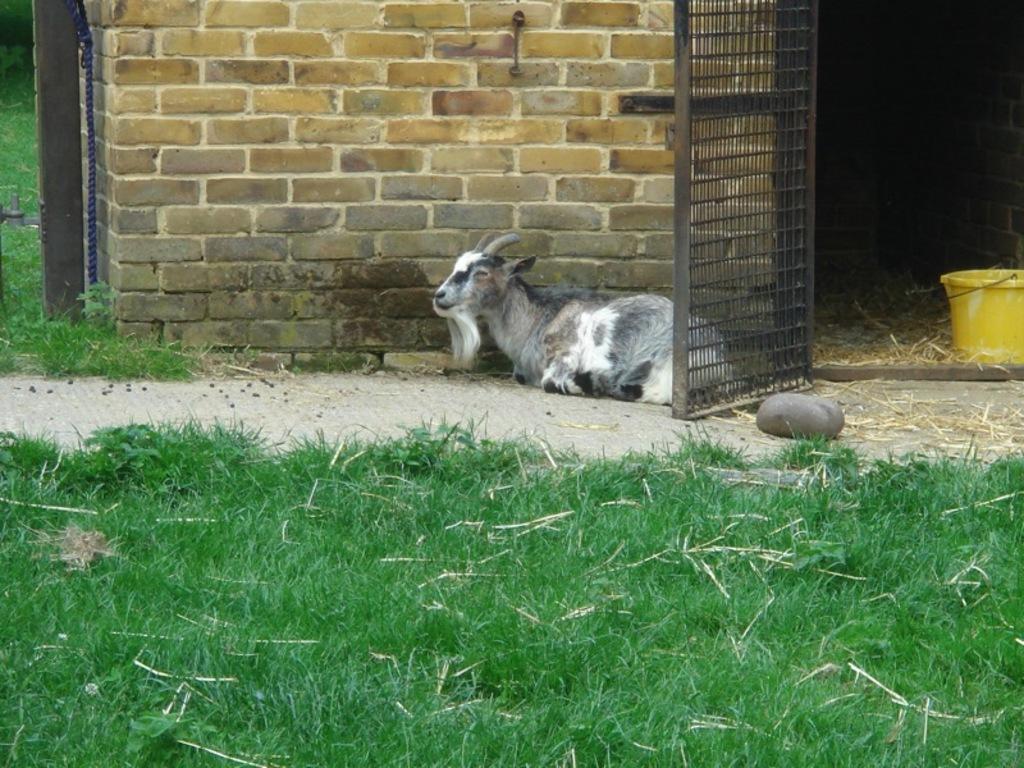In one or two sentences, can you explain what this image depicts? In the foreground of this image, there is goat sitting on the ground and at bottom there is a grass. On right, we see a yellow colored bucket, a stone and a door. On top, there is a wall and a pole. 